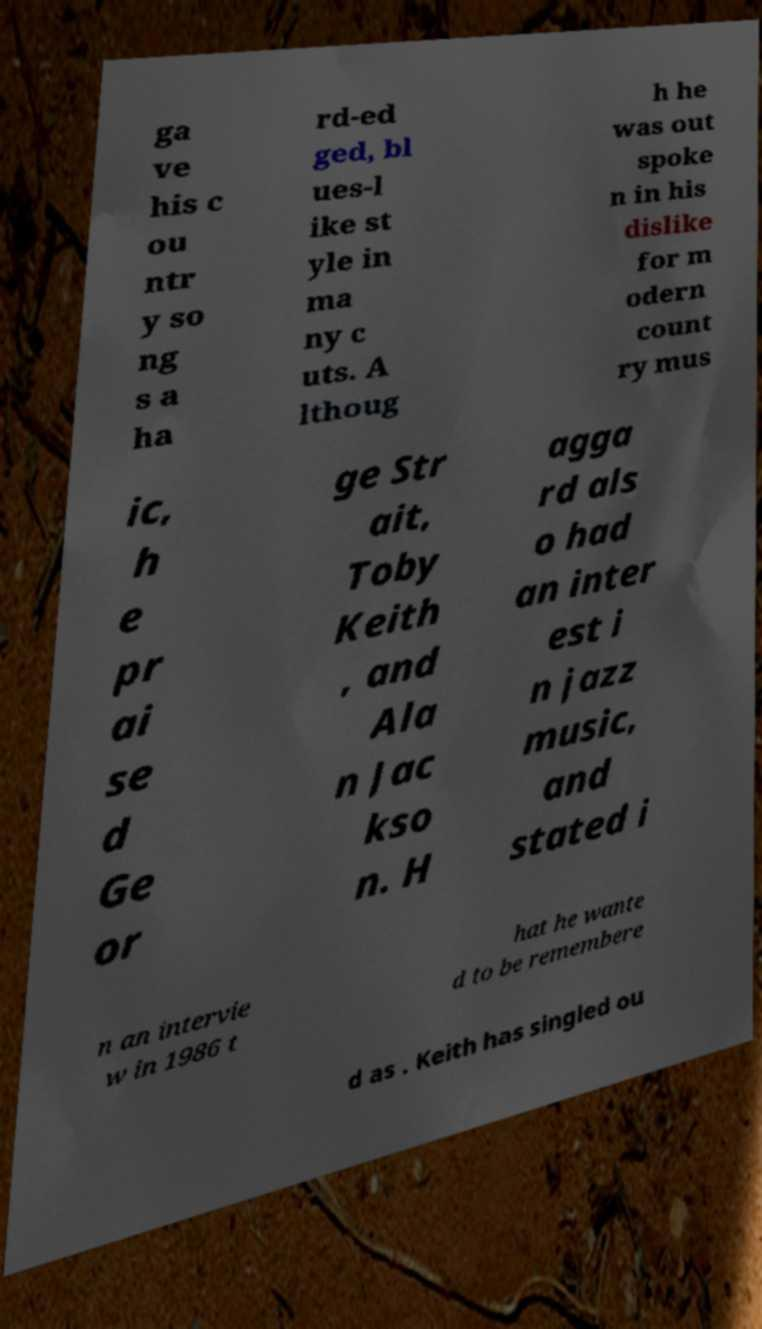I need the written content from this picture converted into text. Can you do that? ga ve his c ou ntr y so ng s a ha rd-ed ged, bl ues-l ike st yle in ma ny c uts. A lthoug h he was out spoke n in his dislike for m odern count ry mus ic, h e pr ai se d Ge or ge Str ait, Toby Keith , and Ala n Jac kso n. H agga rd als o had an inter est i n jazz music, and stated i n an intervie w in 1986 t hat he wante d to be remembere d as . Keith has singled ou 